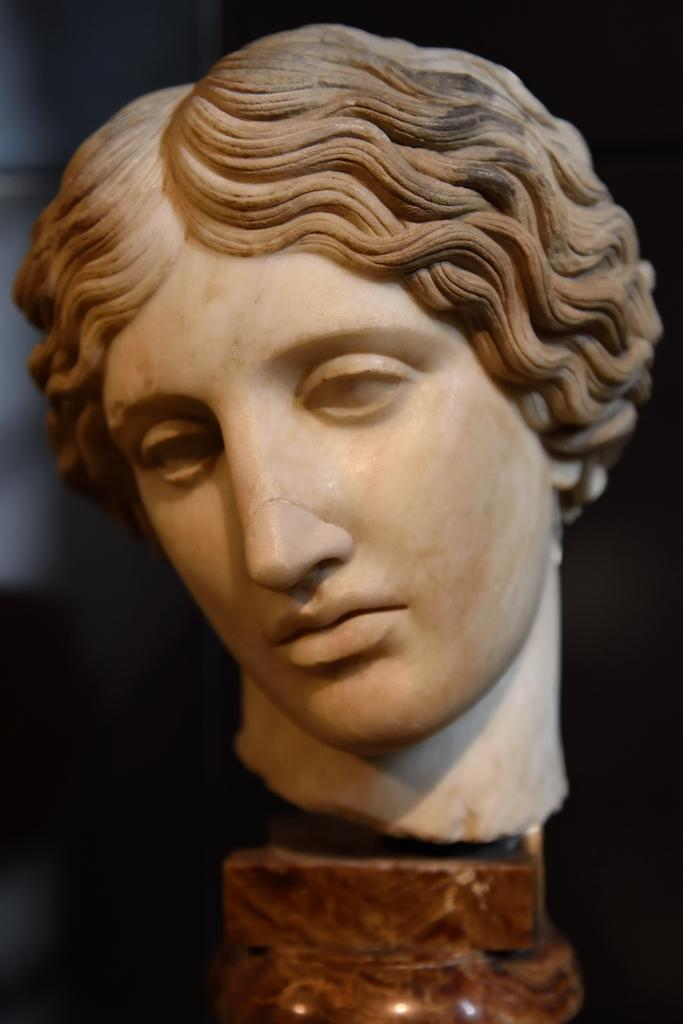What is the main subject in the center of the image? There is a statue in the center of the image. What type of pancake is being served at the event in the image? There is no event or pancake present in the image; it only features a statue. 